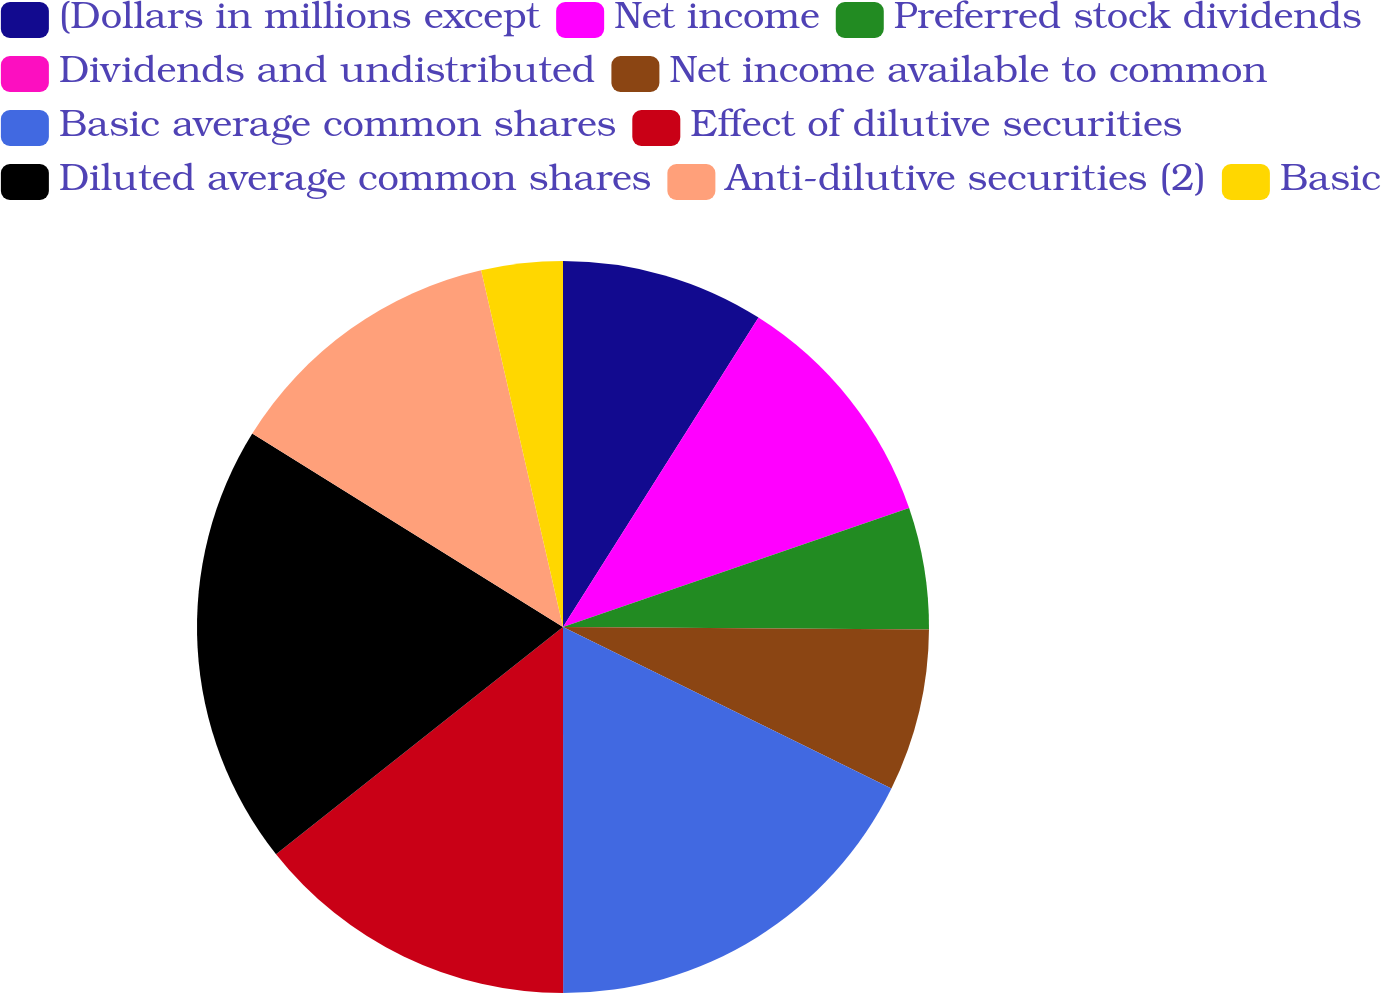Convert chart to OTSL. <chart><loc_0><loc_0><loc_500><loc_500><pie_chart><fcel>(Dollars in millions except<fcel>Net income<fcel>Preferred stock dividends<fcel>Dividends and undistributed<fcel>Net income available to common<fcel>Basic average common shares<fcel>Effect of dilutive securities<fcel>Diluted average common shares<fcel>Anti-dilutive securities (2)<fcel>Basic<nl><fcel>8.97%<fcel>10.76%<fcel>5.38%<fcel>0.0%<fcel>7.17%<fcel>17.72%<fcel>14.35%<fcel>19.52%<fcel>12.55%<fcel>3.59%<nl></chart> 